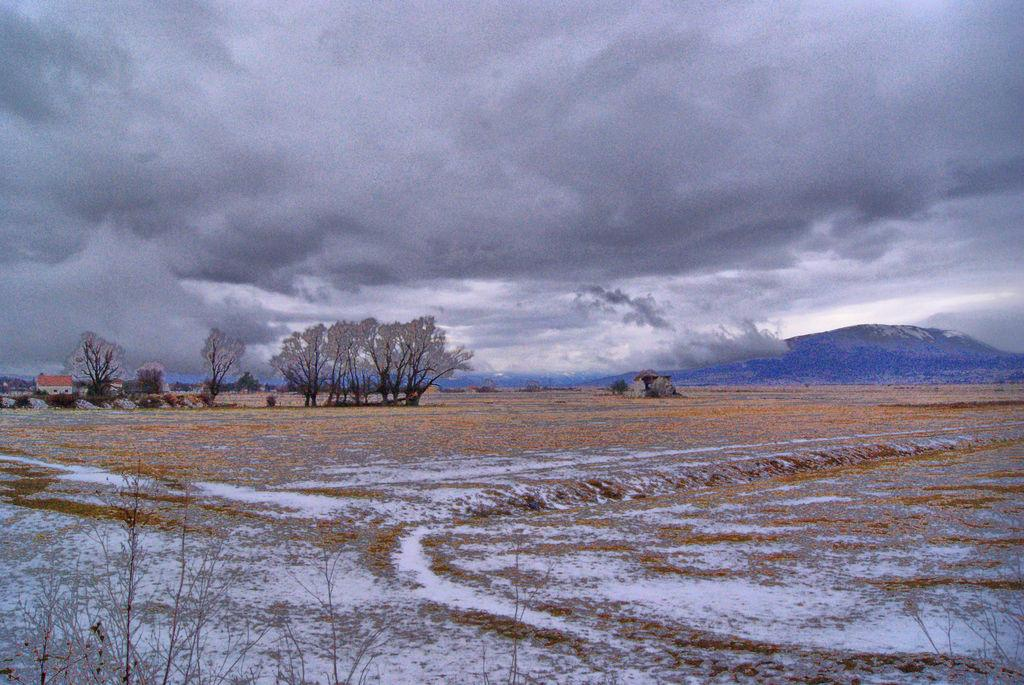What can be seen in the front of the image? There is land in the front of the image. What is located on the left side of the image? There are trees and houses on the left side of the image. What is visible at the back of the image? There are mountains at the back of the image. What is present in the sky in the image? There are clouds in the sky. Can you tell me how many rocks are visible on the right side of the image? There is no mention of rocks in the image, so it is not possible to determine how many are visible. What type of rod is being used by the trees on the left side of the image? There is no rod present in the image; the trees are standing on their own. 